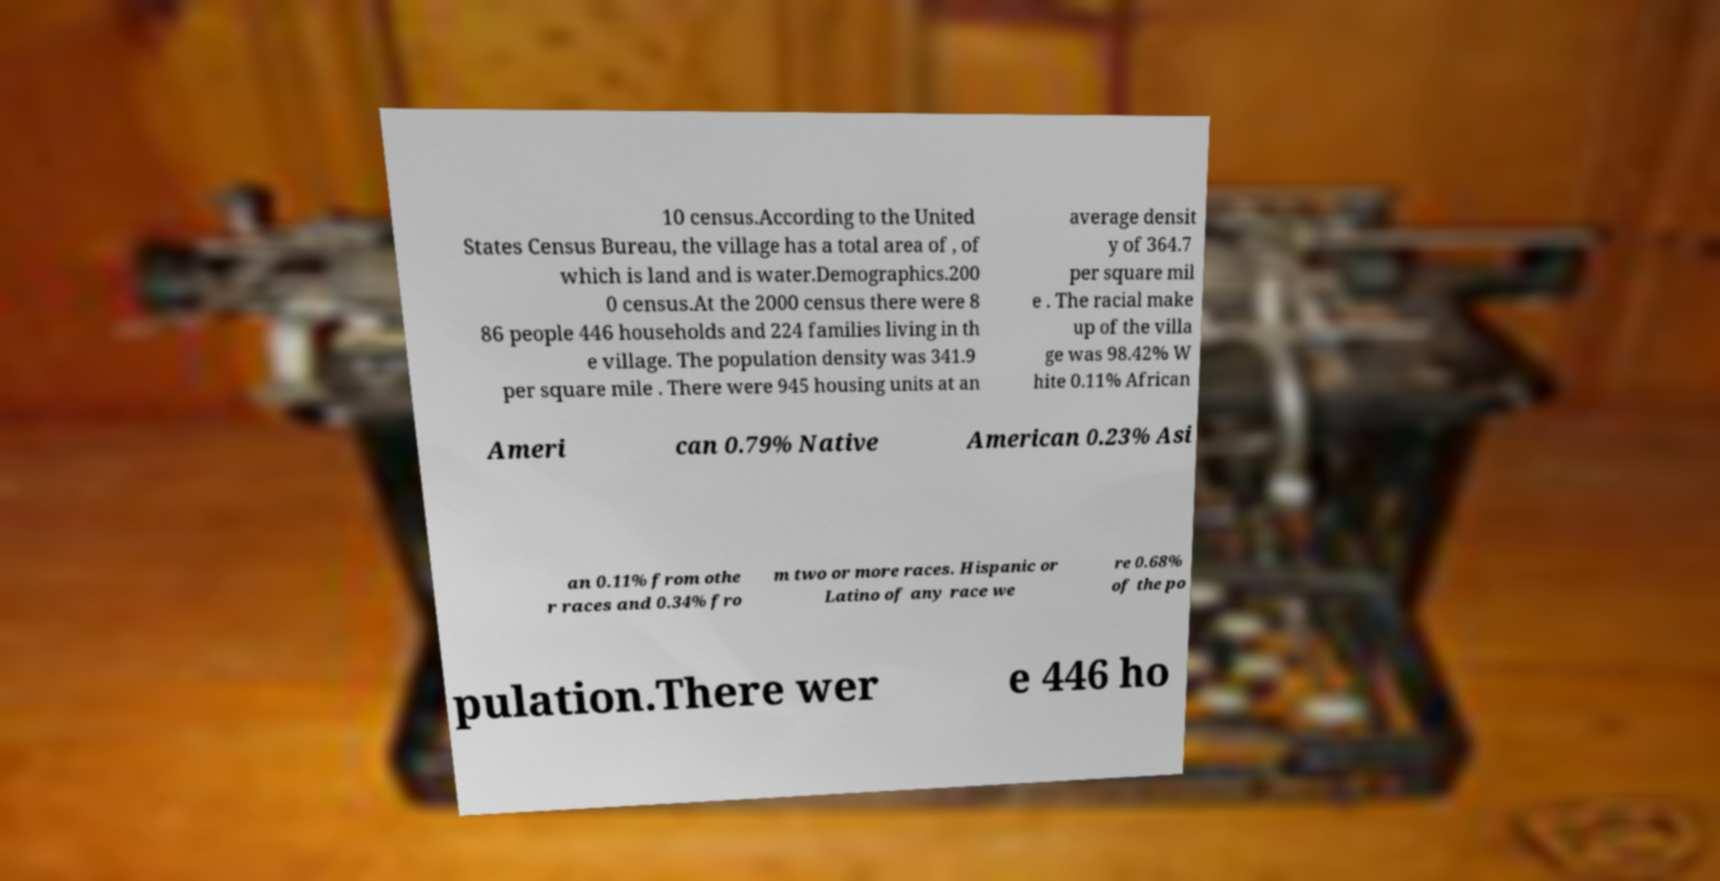Could you extract and type out the text from this image? 10 census.According to the United States Census Bureau, the village has a total area of , of which is land and is water.Demographics.200 0 census.At the 2000 census there were 8 86 people 446 households and 224 families living in th e village. The population density was 341.9 per square mile . There were 945 housing units at an average densit y of 364.7 per square mil e . The racial make up of the villa ge was 98.42% W hite 0.11% African Ameri can 0.79% Native American 0.23% Asi an 0.11% from othe r races and 0.34% fro m two or more races. Hispanic or Latino of any race we re 0.68% of the po pulation.There wer e 446 ho 